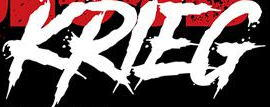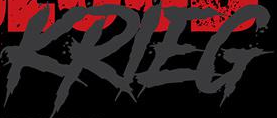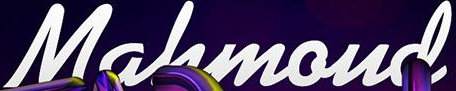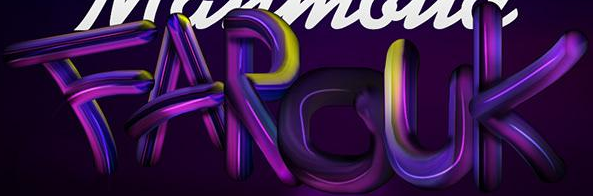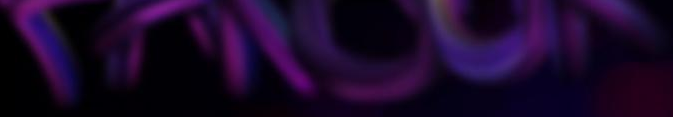What text appears in these images from left to right, separated by a semicolon? KRIEG; KRIEG; Mahmoud; FAROUK; ###### 